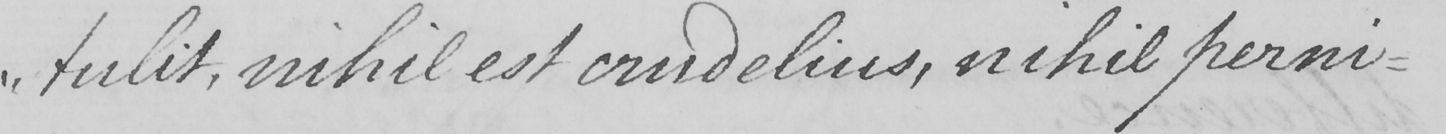What does this handwritten line say? " tulit , nihil est crudelius , nihil perni- 